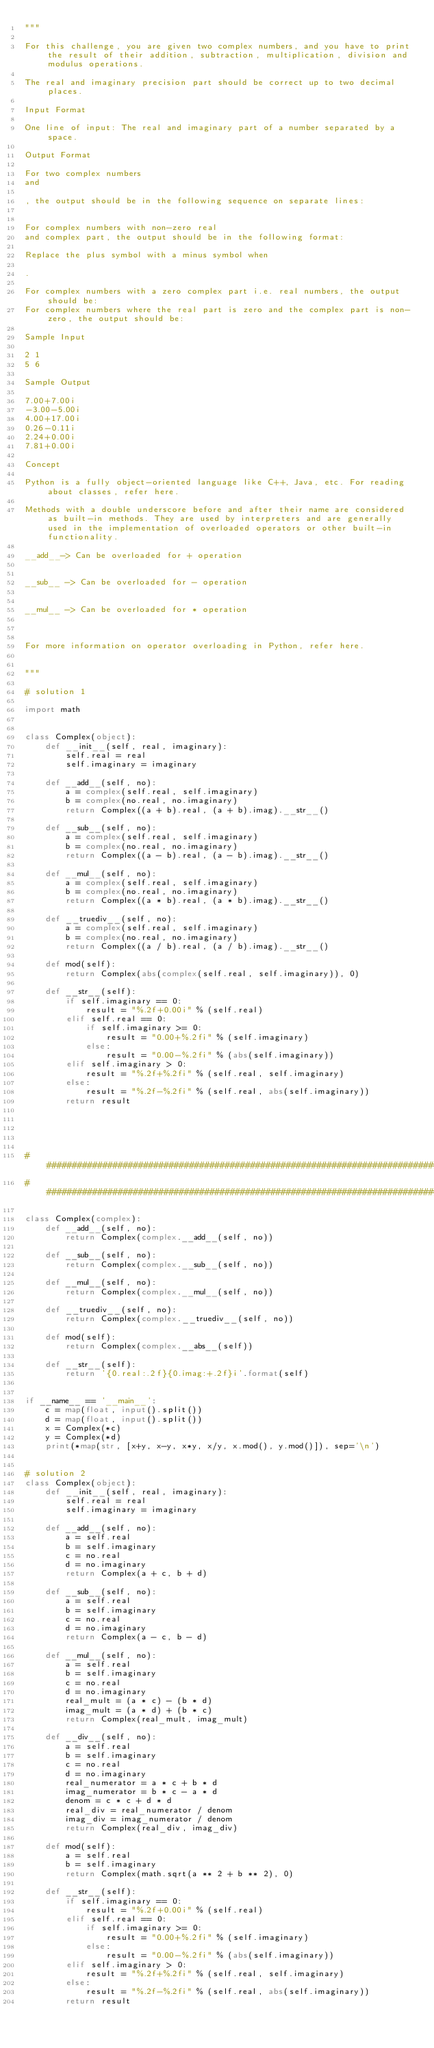<code> <loc_0><loc_0><loc_500><loc_500><_Python_>"""

For this challenge, you are given two complex numbers, and you have to print the result of their addition, subtraction, multiplication, division and modulus operations.

The real and imaginary precision part should be correct up to two decimal places.

Input Format

One line of input: The real and imaginary part of a number separated by a space.

Output Format

For two complex numbers
and

, the output should be in the following sequence on separate lines:


For complex numbers with non-zero real
and complex part, the output should be in the following format:

Replace the plus symbol with a minus symbol when

.

For complex numbers with a zero complex part i.e. real numbers, the output should be:
For complex numbers where the real part is zero and the complex part is non-zero, the output should be:

Sample Input

2 1
5 6

Sample Output

7.00+7.00i
-3.00-5.00i
4.00+17.00i
0.26-0.11i
2.24+0.00i
7.81+0.00i

Concept

Python is a fully object-oriented language like C++, Java, etc. For reading about classes, refer here.

Methods with a double underscore before and after their name are considered as built-in methods. They are used by interpreters and are generally used in the implementation of overloaded operators or other built-in functionality.

__add__-> Can be overloaded for + operation


__sub__ -> Can be overloaded for - operation


__mul__ -> Can be overloaded for * operation



For more information on operator overloading in Python, refer here.


"""

# solution 1

import math


class Complex(object):
    def __init__(self, real, imaginary):
        self.real = real
        self.imaginary = imaginary

    def __add__(self, no):
        a = complex(self.real, self.imaginary)
        b = complex(no.real, no.imaginary)
        return Complex((a + b).real, (a + b).imag).__str__()

    def __sub__(self, no):
        a = complex(self.real, self.imaginary)
        b = complex(no.real, no.imaginary)
        return Complex((a - b).real, (a - b).imag).__str__()

    def __mul__(self, no):
        a = complex(self.real, self.imaginary)
        b = complex(no.real, no.imaginary)
        return Complex((a * b).real, (a * b).imag).__str__()

    def __truediv__(self, no):
        a = complex(self.real, self.imaginary)
        b = complex(no.real, no.imaginary)
        return Complex((a / b).real, (a / b).imag).__str__()

    def mod(self):
        return Complex(abs(complex(self.real, self.imaginary)), 0)

    def __str__(self):
        if self.imaginary == 0:
            result = "%.2f+0.00i" % (self.real)
        elif self.real == 0:
            if self.imaginary >= 0:
                result = "0.00+%.2fi" % (self.imaginary)
            else:
                result = "0.00-%.2fi" % (abs(self.imaginary))
        elif self.imaginary > 0:
            result = "%.2f+%.2fi" % (self.real, self.imaginary)
        else:
            result = "%.2f-%.2fi" % (self.real, abs(self.imaginary))
        return result





#####################################################################################
#####################################################################################

class Complex(complex):
    def __add__(self, no):
        return Complex(complex.__add__(self, no))

    def __sub__(self, no):
        return Complex(complex.__sub__(self, no))

    def __mul__(self, no):
        return Complex(complex.__mul__(self, no))

    def __truediv__(self, no):
        return Complex(complex.__truediv__(self, no))

    def mod(self):
        return Complex(complex.__abs__(self))

    def __str__(self):
        return '{0.real:.2f}{0.imag:+.2f}i'.format(self)


if __name__ == '__main__':
    c = map(float, input().split())
    d = map(float, input().split())
    x = Complex(*c)
    y = Complex(*d)
    print(*map(str, [x+y, x-y, x*y, x/y, x.mod(), y.mod()]), sep='\n')


# solution 2
class Complex(object):
    def __init__(self, real, imaginary):
        self.real = real
        self.imaginary = imaginary

    def __add__(self, no):
        a = self.real
        b = self.imaginary
        c = no.real
        d = no.imaginary
        return Complex(a + c, b + d)

    def __sub__(self, no):
        a = self.real
        b = self.imaginary
        c = no.real
        d = no.imaginary
        return Complex(a - c, b - d)

    def __mul__(self, no):
        a = self.real
        b = self.imaginary
        c = no.real
        d = no.imaginary
        real_mult = (a * c) - (b * d)
        imag_mult = (a * d) + (b * c)
        return Complex(real_mult, imag_mult)

    def __div__(self, no):
        a = self.real
        b = self.imaginary
        c = no.real
        d = no.imaginary
        real_numerator = a * c + b * d
        imag_numerator = b * c - a * d
        denom = c * c + d * d
        real_div = real_numerator / denom
        imag_div = imag_numerator / denom
        return Complex(real_div, imag_div)

    def mod(self):
        a = self.real
        b = self.imaginary
        return Complex(math.sqrt(a ** 2 + b ** 2), 0)

    def __str__(self):
        if self.imaginary == 0:
            result = "%.2f+0.00i" % (self.real)
        elif self.real == 0:
            if self.imaginary >= 0:
                result = "0.00+%.2fi" % (self.imaginary)
            else:
                result = "0.00-%.2fi" % (abs(self.imaginary))
        elif self.imaginary > 0:
            result = "%.2f+%.2fi" % (self.real, self.imaginary)
        else:
            result = "%.2f-%.2fi" % (self.real, abs(self.imaginary))
        return result









</code> 